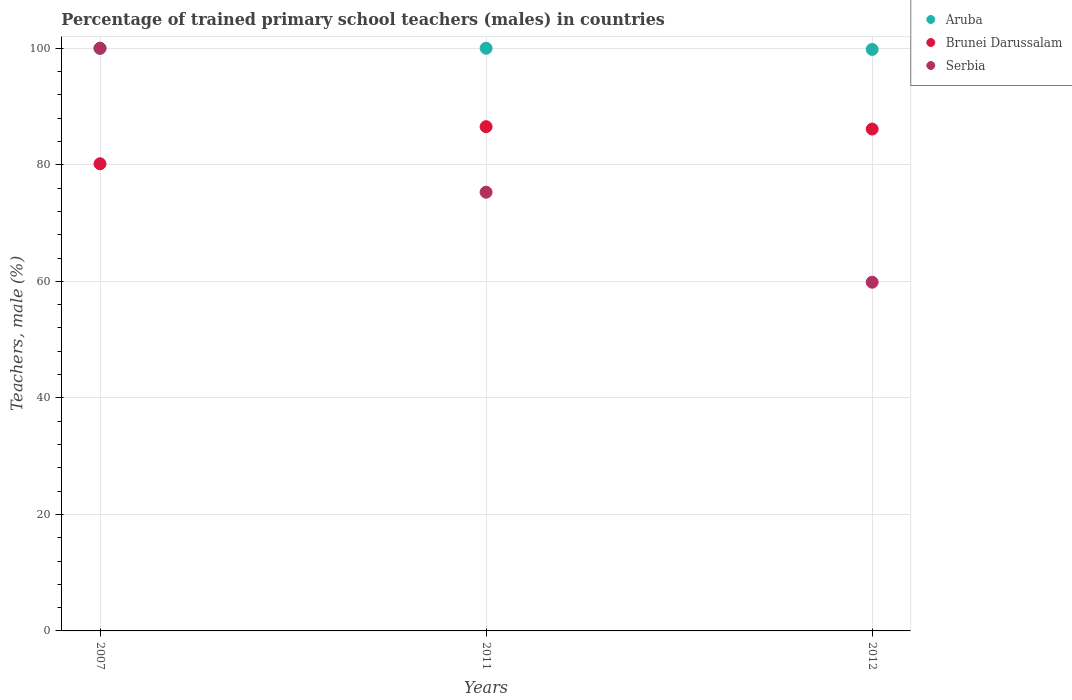Is the number of dotlines equal to the number of legend labels?
Offer a terse response. Yes. What is the percentage of trained primary school teachers (males) in Aruba in 2012?
Your response must be concise. 99.8. Across all years, what is the maximum percentage of trained primary school teachers (males) in Brunei Darussalam?
Ensure brevity in your answer.  86.54. Across all years, what is the minimum percentage of trained primary school teachers (males) in Aruba?
Your answer should be compact. 99.8. In which year was the percentage of trained primary school teachers (males) in Aruba maximum?
Provide a succinct answer. 2007. What is the total percentage of trained primary school teachers (males) in Serbia in the graph?
Ensure brevity in your answer.  235.14. What is the difference between the percentage of trained primary school teachers (males) in Brunei Darussalam in 2007 and that in 2011?
Your answer should be very brief. -6.36. What is the difference between the percentage of trained primary school teachers (males) in Brunei Darussalam in 2011 and the percentage of trained primary school teachers (males) in Aruba in 2012?
Make the answer very short. -13.26. What is the average percentage of trained primary school teachers (males) in Brunei Darussalam per year?
Make the answer very short. 84.29. In the year 2011, what is the difference between the percentage of trained primary school teachers (males) in Brunei Darussalam and percentage of trained primary school teachers (males) in Aruba?
Give a very brief answer. -13.46. What is the ratio of the percentage of trained primary school teachers (males) in Aruba in 2007 to that in 2011?
Your response must be concise. 1. Is the percentage of trained primary school teachers (males) in Serbia in 2007 less than that in 2011?
Keep it short and to the point. No. What is the difference between the highest and the second highest percentage of trained primary school teachers (males) in Serbia?
Your answer should be very brief. 24.7. What is the difference between the highest and the lowest percentage of trained primary school teachers (males) in Serbia?
Your answer should be very brief. 40.15. Is the sum of the percentage of trained primary school teachers (males) in Brunei Darussalam in 2011 and 2012 greater than the maximum percentage of trained primary school teachers (males) in Serbia across all years?
Your answer should be compact. Yes. Is it the case that in every year, the sum of the percentage of trained primary school teachers (males) in Brunei Darussalam and percentage of trained primary school teachers (males) in Serbia  is greater than the percentage of trained primary school teachers (males) in Aruba?
Your answer should be very brief. Yes. Does the percentage of trained primary school teachers (males) in Serbia monotonically increase over the years?
Keep it short and to the point. No. What is the difference between two consecutive major ticks on the Y-axis?
Provide a short and direct response. 20. Are the values on the major ticks of Y-axis written in scientific E-notation?
Provide a succinct answer. No. Does the graph contain any zero values?
Make the answer very short. No. Does the graph contain grids?
Keep it short and to the point. Yes. Where does the legend appear in the graph?
Give a very brief answer. Top right. How are the legend labels stacked?
Offer a very short reply. Vertical. What is the title of the graph?
Keep it short and to the point. Percentage of trained primary school teachers (males) in countries. Does "Middle East & North Africa (developing only)" appear as one of the legend labels in the graph?
Give a very brief answer. No. What is the label or title of the Y-axis?
Your answer should be very brief. Teachers, male (%). What is the Teachers, male (%) of Brunei Darussalam in 2007?
Your response must be concise. 80.18. What is the Teachers, male (%) in Serbia in 2007?
Provide a succinct answer. 100. What is the Teachers, male (%) of Aruba in 2011?
Keep it short and to the point. 100. What is the Teachers, male (%) of Brunei Darussalam in 2011?
Provide a short and direct response. 86.54. What is the Teachers, male (%) of Serbia in 2011?
Give a very brief answer. 75.3. What is the Teachers, male (%) of Aruba in 2012?
Your response must be concise. 99.8. What is the Teachers, male (%) of Brunei Darussalam in 2012?
Ensure brevity in your answer.  86.13. What is the Teachers, male (%) of Serbia in 2012?
Give a very brief answer. 59.85. Across all years, what is the maximum Teachers, male (%) of Brunei Darussalam?
Provide a short and direct response. 86.54. Across all years, what is the maximum Teachers, male (%) in Serbia?
Provide a short and direct response. 100. Across all years, what is the minimum Teachers, male (%) in Aruba?
Keep it short and to the point. 99.8. Across all years, what is the minimum Teachers, male (%) in Brunei Darussalam?
Your answer should be compact. 80.18. Across all years, what is the minimum Teachers, male (%) in Serbia?
Your answer should be compact. 59.85. What is the total Teachers, male (%) of Aruba in the graph?
Your answer should be compact. 299.8. What is the total Teachers, male (%) in Brunei Darussalam in the graph?
Give a very brief answer. 252.86. What is the total Teachers, male (%) of Serbia in the graph?
Your answer should be very brief. 235.14. What is the difference between the Teachers, male (%) in Brunei Darussalam in 2007 and that in 2011?
Make the answer very short. -6.36. What is the difference between the Teachers, male (%) in Serbia in 2007 and that in 2011?
Give a very brief answer. 24.7. What is the difference between the Teachers, male (%) in Aruba in 2007 and that in 2012?
Provide a short and direct response. 0.2. What is the difference between the Teachers, male (%) in Brunei Darussalam in 2007 and that in 2012?
Your response must be concise. -5.96. What is the difference between the Teachers, male (%) of Serbia in 2007 and that in 2012?
Offer a very short reply. 40.15. What is the difference between the Teachers, male (%) of Aruba in 2011 and that in 2012?
Make the answer very short. 0.2. What is the difference between the Teachers, male (%) of Brunei Darussalam in 2011 and that in 2012?
Provide a succinct answer. 0.41. What is the difference between the Teachers, male (%) in Serbia in 2011 and that in 2012?
Make the answer very short. 15.45. What is the difference between the Teachers, male (%) of Aruba in 2007 and the Teachers, male (%) of Brunei Darussalam in 2011?
Keep it short and to the point. 13.46. What is the difference between the Teachers, male (%) of Aruba in 2007 and the Teachers, male (%) of Serbia in 2011?
Ensure brevity in your answer.  24.7. What is the difference between the Teachers, male (%) in Brunei Darussalam in 2007 and the Teachers, male (%) in Serbia in 2011?
Your response must be concise. 4.88. What is the difference between the Teachers, male (%) in Aruba in 2007 and the Teachers, male (%) in Brunei Darussalam in 2012?
Make the answer very short. 13.87. What is the difference between the Teachers, male (%) of Aruba in 2007 and the Teachers, male (%) of Serbia in 2012?
Keep it short and to the point. 40.15. What is the difference between the Teachers, male (%) of Brunei Darussalam in 2007 and the Teachers, male (%) of Serbia in 2012?
Provide a succinct answer. 20.33. What is the difference between the Teachers, male (%) of Aruba in 2011 and the Teachers, male (%) of Brunei Darussalam in 2012?
Give a very brief answer. 13.87. What is the difference between the Teachers, male (%) in Aruba in 2011 and the Teachers, male (%) in Serbia in 2012?
Keep it short and to the point. 40.15. What is the difference between the Teachers, male (%) of Brunei Darussalam in 2011 and the Teachers, male (%) of Serbia in 2012?
Keep it short and to the point. 26.7. What is the average Teachers, male (%) of Aruba per year?
Offer a terse response. 99.93. What is the average Teachers, male (%) of Brunei Darussalam per year?
Ensure brevity in your answer.  84.29. What is the average Teachers, male (%) in Serbia per year?
Ensure brevity in your answer.  78.38. In the year 2007, what is the difference between the Teachers, male (%) of Aruba and Teachers, male (%) of Brunei Darussalam?
Your answer should be compact. 19.82. In the year 2007, what is the difference between the Teachers, male (%) of Brunei Darussalam and Teachers, male (%) of Serbia?
Provide a succinct answer. -19.82. In the year 2011, what is the difference between the Teachers, male (%) of Aruba and Teachers, male (%) of Brunei Darussalam?
Your response must be concise. 13.46. In the year 2011, what is the difference between the Teachers, male (%) of Aruba and Teachers, male (%) of Serbia?
Provide a short and direct response. 24.7. In the year 2011, what is the difference between the Teachers, male (%) in Brunei Darussalam and Teachers, male (%) in Serbia?
Provide a succinct answer. 11.25. In the year 2012, what is the difference between the Teachers, male (%) in Aruba and Teachers, male (%) in Brunei Darussalam?
Your answer should be compact. 13.67. In the year 2012, what is the difference between the Teachers, male (%) in Aruba and Teachers, male (%) in Serbia?
Provide a short and direct response. 39.95. In the year 2012, what is the difference between the Teachers, male (%) of Brunei Darussalam and Teachers, male (%) of Serbia?
Your response must be concise. 26.29. What is the ratio of the Teachers, male (%) of Brunei Darussalam in 2007 to that in 2011?
Your response must be concise. 0.93. What is the ratio of the Teachers, male (%) of Serbia in 2007 to that in 2011?
Ensure brevity in your answer.  1.33. What is the ratio of the Teachers, male (%) in Brunei Darussalam in 2007 to that in 2012?
Ensure brevity in your answer.  0.93. What is the ratio of the Teachers, male (%) in Serbia in 2007 to that in 2012?
Make the answer very short. 1.67. What is the ratio of the Teachers, male (%) of Aruba in 2011 to that in 2012?
Ensure brevity in your answer.  1. What is the ratio of the Teachers, male (%) of Serbia in 2011 to that in 2012?
Offer a terse response. 1.26. What is the difference between the highest and the second highest Teachers, male (%) in Aruba?
Give a very brief answer. 0. What is the difference between the highest and the second highest Teachers, male (%) of Brunei Darussalam?
Offer a terse response. 0.41. What is the difference between the highest and the second highest Teachers, male (%) of Serbia?
Make the answer very short. 24.7. What is the difference between the highest and the lowest Teachers, male (%) of Aruba?
Offer a very short reply. 0.2. What is the difference between the highest and the lowest Teachers, male (%) in Brunei Darussalam?
Make the answer very short. 6.36. What is the difference between the highest and the lowest Teachers, male (%) in Serbia?
Your response must be concise. 40.15. 